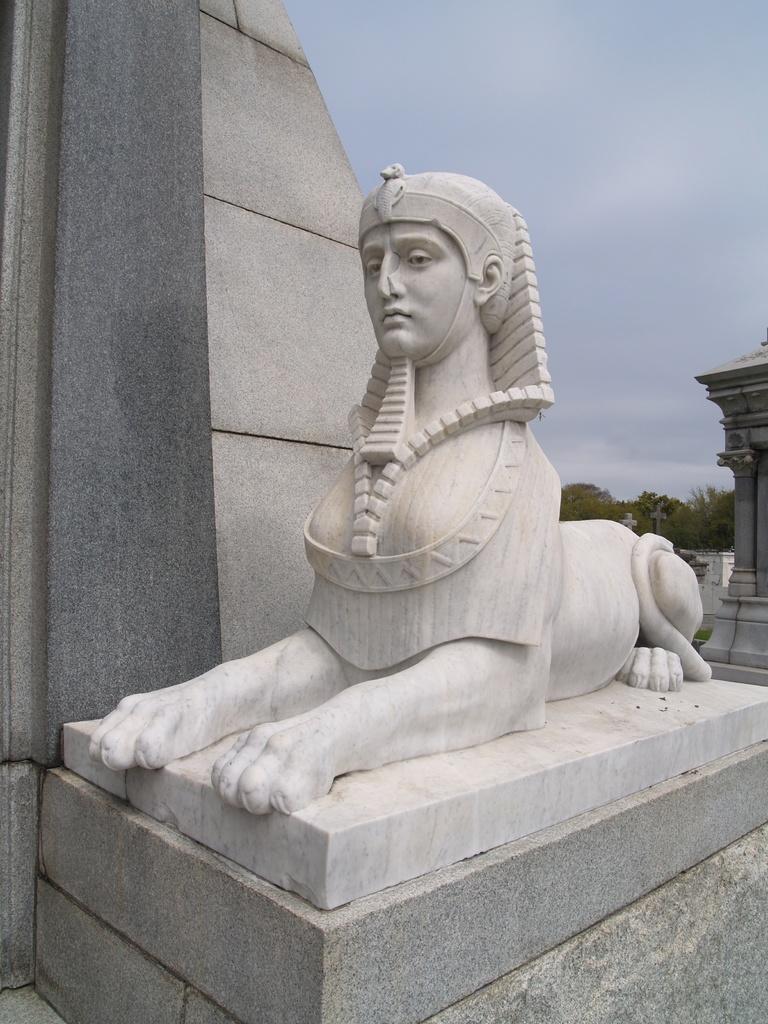In one or two sentences, can you explain what this image depicts? In this picture there is a statue in the foreground. At the back there are trees and their might be a building. At the top there is sky. 